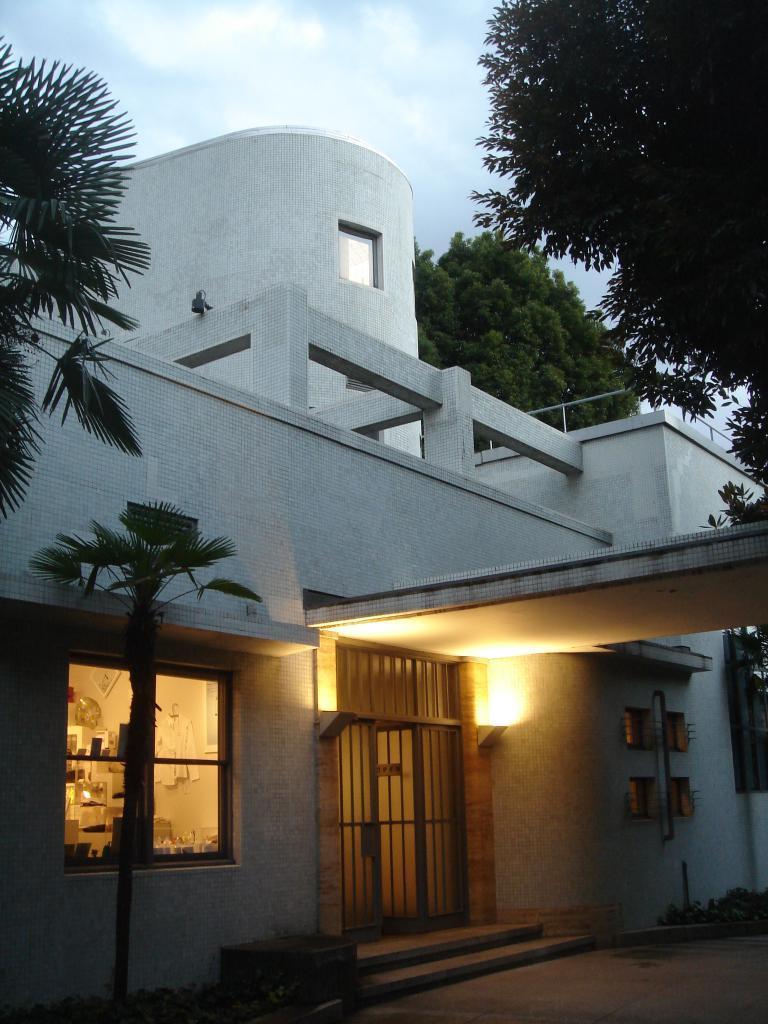Could you give a brief overview of what you see in this image? This is an outside view. In the middle of this image there is a building. Here I can see a window, a light and also there is a metal frame. In the background there are some trees. At the top of the image I can see the sky. 